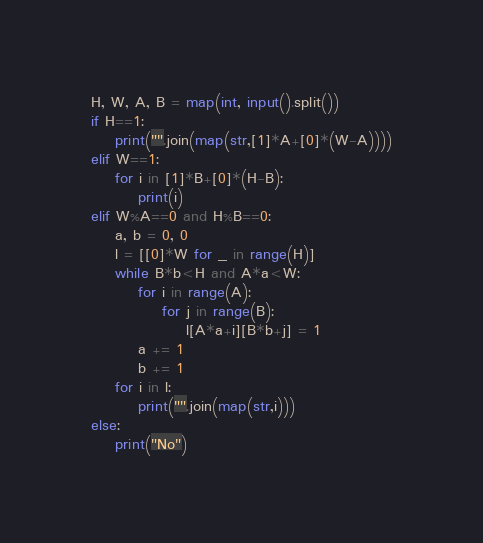<code> <loc_0><loc_0><loc_500><loc_500><_Python_>H, W, A, B = map(int, input().split())
if H==1:
    print("".join(map(str,[1]*A+[0]*(W-A))))
elif W==1:
    for i in [1]*B+[0]*(H-B):
        print(i)
elif W%A==0 and H%B==0:
    a, b = 0, 0
    l = [[0]*W for _ in range(H)]
    while B*b<H and A*a<W:
        for i in range(A):
            for j in range(B):
                l[A*a+i][B*b+j] = 1
        a += 1
        b += 1
    for i in l:
        print("".join(map(str,i)))
else:
    print("No")</code> 